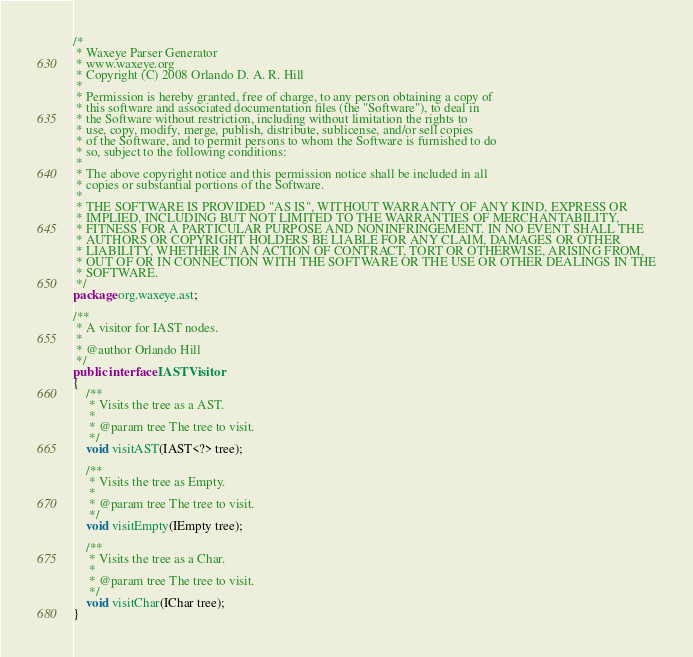<code> <loc_0><loc_0><loc_500><loc_500><_Java_>/*
 * Waxeye Parser Generator
 * www.waxeye.org
 * Copyright (C) 2008 Orlando D. A. R. Hill
 *
 * Permission is hereby granted, free of charge, to any person obtaining a copy of
 * this software and associated documentation files (the "Software"), to deal in
 * the Software without restriction, including without limitation the rights to
 * use, copy, modify, merge, publish, distribute, sublicense, and/or sell copies
 * of the Software, and to permit persons to whom the Software is furnished to do
 * so, subject to the following conditions:
 *
 * The above copyright notice and this permission notice shall be included in all
 * copies or substantial portions of the Software.
 *
 * THE SOFTWARE IS PROVIDED "AS IS", WITHOUT WARRANTY OF ANY KIND, EXPRESS OR
 * IMPLIED, INCLUDING BUT NOT LIMITED TO THE WARRANTIES OF MERCHANTABILITY,
 * FITNESS FOR A PARTICULAR PURPOSE AND NONINFRINGEMENT. IN NO EVENT SHALL THE
 * AUTHORS OR COPYRIGHT HOLDERS BE LIABLE FOR ANY CLAIM, DAMAGES OR OTHER
 * LIABILITY, WHETHER IN AN ACTION OF CONTRACT, TORT OR OTHERWISE, ARISING FROM,
 * OUT OF OR IN CONNECTION WITH THE SOFTWARE OR THE USE OR OTHER DEALINGS IN THE
 * SOFTWARE.
 */
package org.waxeye.ast;

/**
 * A visitor for IAST nodes.
 *
 * @author Orlando Hill
 */
public interface IASTVisitor
{
    /**
     * Visits the tree as a AST.
     *
     * @param tree The tree to visit.
     */
    void visitAST(IAST<?> tree);

    /**
     * Visits the tree as Empty.
     *
     * @param tree The tree to visit.
     */
    void visitEmpty(IEmpty tree);

    /**
     * Visits the tree as a Char.
     *
     * @param tree The tree to visit.
     */
    void visitChar(IChar tree);
}
</code> 